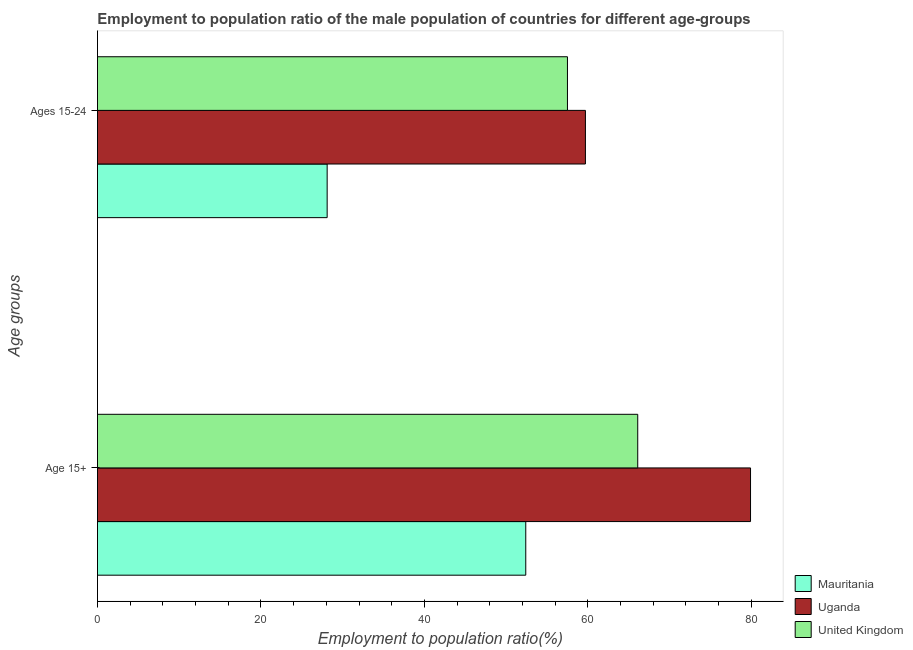Are the number of bars per tick equal to the number of legend labels?
Give a very brief answer. Yes. Are the number of bars on each tick of the Y-axis equal?
Give a very brief answer. Yes. How many bars are there on the 2nd tick from the top?
Offer a very short reply. 3. How many bars are there on the 2nd tick from the bottom?
Provide a short and direct response. 3. What is the label of the 1st group of bars from the top?
Keep it short and to the point. Ages 15-24. What is the employment to population ratio(age 15+) in Uganda?
Make the answer very short. 79.9. Across all countries, what is the maximum employment to population ratio(age 15+)?
Ensure brevity in your answer.  79.9. Across all countries, what is the minimum employment to population ratio(age 15+)?
Offer a terse response. 52.4. In which country was the employment to population ratio(age 15+) maximum?
Offer a very short reply. Uganda. In which country was the employment to population ratio(age 15-24) minimum?
Offer a very short reply. Mauritania. What is the total employment to population ratio(age 15-24) in the graph?
Provide a short and direct response. 145.3. What is the difference between the employment to population ratio(age 15+) in United Kingdom and that in Uganda?
Provide a short and direct response. -13.8. What is the difference between the employment to population ratio(age 15-24) in Mauritania and the employment to population ratio(age 15+) in Uganda?
Offer a terse response. -51.8. What is the average employment to population ratio(age 15-24) per country?
Your answer should be very brief. 48.43. What is the difference between the employment to population ratio(age 15+) and employment to population ratio(age 15-24) in Uganda?
Give a very brief answer. 20.2. What is the ratio of the employment to population ratio(age 15+) in Mauritania to that in United Kingdom?
Offer a terse response. 0.79. Is the employment to population ratio(age 15-24) in Mauritania less than that in Uganda?
Make the answer very short. Yes. In how many countries, is the employment to population ratio(age 15+) greater than the average employment to population ratio(age 15+) taken over all countries?
Offer a very short reply. 1. What does the 3rd bar from the top in Age 15+ represents?
Your response must be concise. Mauritania. What does the 2nd bar from the bottom in Age 15+ represents?
Provide a short and direct response. Uganda. How many bars are there?
Keep it short and to the point. 6. What is the difference between two consecutive major ticks on the X-axis?
Give a very brief answer. 20. Does the graph contain any zero values?
Offer a terse response. No. Does the graph contain grids?
Your response must be concise. No. Where does the legend appear in the graph?
Your answer should be compact. Bottom right. How many legend labels are there?
Your answer should be compact. 3. What is the title of the graph?
Your answer should be very brief. Employment to population ratio of the male population of countries for different age-groups. Does "South Sudan" appear as one of the legend labels in the graph?
Your answer should be compact. No. What is the label or title of the X-axis?
Make the answer very short. Employment to population ratio(%). What is the label or title of the Y-axis?
Offer a very short reply. Age groups. What is the Employment to population ratio(%) in Mauritania in Age 15+?
Your answer should be compact. 52.4. What is the Employment to population ratio(%) of Uganda in Age 15+?
Make the answer very short. 79.9. What is the Employment to population ratio(%) in United Kingdom in Age 15+?
Offer a terse response. 66.1. What is the Employment to population ratio(%) of Mauritania in Ages 15-24?
Give a very brief answer. 28.1. What is the Employment to population ratio(%) of Uganda in Ages 15-24?
Ensure brevity in your answer.  59.7. What is the Employment to population ratio(%) in United Kingdom in Ages 15-24?
Make the answer very short. 57.5. Across all Age groups, what is the maximum Employment to population ratio(%) of Mauritania?
Offer a very short reply. 52.4. Across all Age groups, what is the maximum Employment to population ratio(%) of Uganda?
Make the answer very short. 79.9. Across all Age groups, what is the maximum Employment to population ratio(%) of United Kingdom?
Provide a short and direct response. 66.1. Across all Age groups, what is the minimum Employment to population ratio(%) of Mauritania?
Ensure brevity in your answer.  28.1. Across all Age groups, what is the minimum Employment to population ratio(%) in Uganda?
Keep it short and to the point. 59.7. Across all Age groups, what is the minimum Employment to population ratio(%) of United Kingdom?
Your response must be concise. 57.5. What is the total Employment to population ratio(%) of Mauritania in the graph?
Your answer should be very brief. 80.5. What is the total Employment to population ratio(%) of Uganda in the graph?
Ensure brevity in your answer.  139.6. What is the total Employment to population ratio(%) in United Kingdom in the graph?
Your response must be concise. 123.6. What is the difference between the Employment to population ratio(%) of Mauritania in Age 15+ and that in Ages 15-24?
Provide a short and direct response. 24.3. What is the difference between the Employment to population ratio(%) in Uganda in Age 15+ and that in Ages 15-24?
Give a very brief answer. 20.2. What is the difference between the Employment to population ratio(%) of United Kingdom in Age 15+ and that in Ages 15-24?
Provide a succinct answer. 8.6. What is the difference between the Employment to population ratio(%) of Mauritania in Age 15+ and the Employment to population ratio(%) of Uganda in Ages 15-24?
Ensure brevity in your answer.  -7.3. What is the difference between the Employment to population ratio(%) of Uganda in Age 15+ and the Employment to population ratio(%) of United Kingdom in Ages 15-24?
Provide a short and direct response. 22.4. What is the average Employment to population ratio(%) of Mauritania per Age groups?
Your answer should be very brief. 40.25. What is the average Employment to population ratio(%) in Uganda per Age groups?
Keep it short and to the point. 69.8. What is the average Employment to population ratio(%) in United Kingdom per Age groups?
Your answer should be very brief. 61.8. What is the difference between the Employment to population ratio(%) of Mauritania and Employment to population ratio(%) of Uganda in Age 15+?
Offer a very short reply. -27.5. What is the difference between the Employment to population ratio(%) of Mauritania and Employment to population ratio(%) of United Kingdom in Age 15+?
Keep it short and to the point. -13.7. What is the difference between the Employment to population ratio(%) in Uganda and Employment to population ratio(%) in United Kingdom in Age 15+?
Your answer should be compact. 13.8. What is the difference between the Employment to population ratio(%) of Mauritania and Employment to population ratio(%) of Uganda in Ages 15-24?
Your answer should be compact. -31.6. What is the difference between the Employment to population ratio(%) of Mauritania and Employment to population ratio(%) of United Kingdom in Ages 15-24?
Your answer should be compact. -29.4. What is the ratio of the Employment to population ratio(%) in Mauritania in Age 15+ to that in Ages 15-24?
Your answer should be compact. 1.86. What is the ratio of the Employment to population ratio(%) in Uganda in Age 15+ to that in Ages 15-24?
Your answer should be very brief. 1.34. What is the ratio of the Employment to population ratio(%) in United Kingdom in Age 15+ to that in Ages 15-24?
Make the answer very short. 1.15. What is the difference between the highest and the second highest Employment to population ratio(%) of Mauritania?
Offer a terse response. 24.3. What is the difference between the highest and the second highest Employment to population ratio(%) of Uganda?
Your response must be concise. 20.2. What is the difference between the highest and the lowest Employment to population ratio(%) in Mauritania?
Give a very brief answer. 24.3. What is the difference between the highest and the lowest Employment to population ratio(%) of Uganda?
Keep it short and to the point. 20.2. 